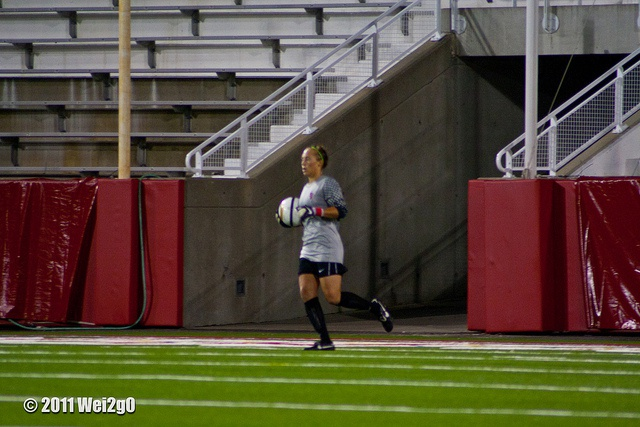Describe the objects in this image and their specific colors. I can see people in black, gray, darkgray, and maroon tones, bench in black and gray tones, bench in black and gray tones, bench in black, gray, and darkgray tones, and bench in black, gray, and darkgray tones in this image. 